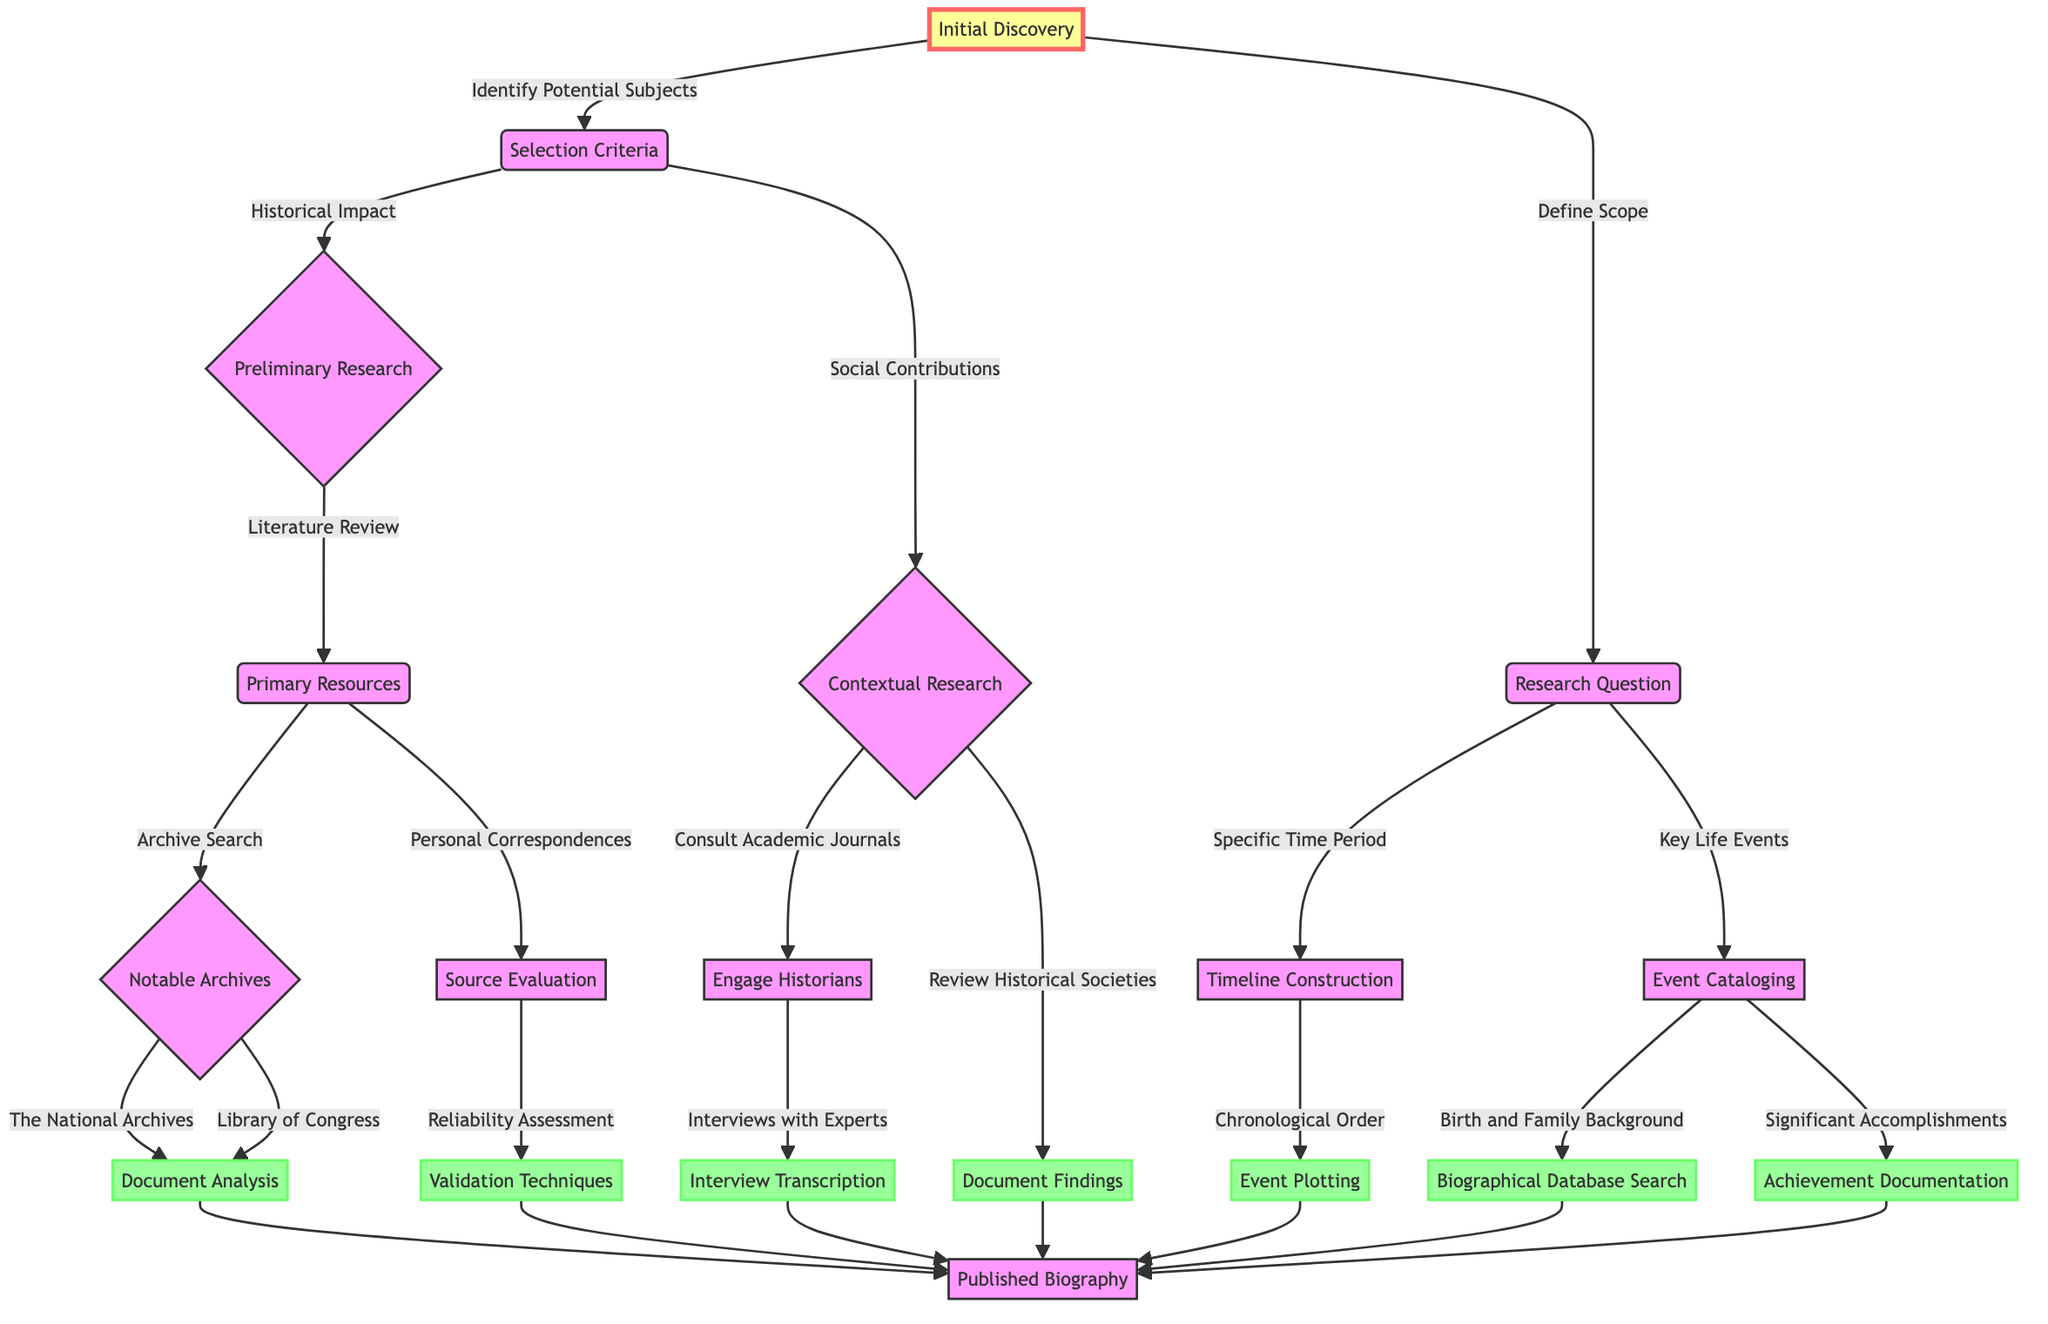What is the initial node in the diagram? The diagram starts with "Initial Discovery" as the first node.
Answer: Initial Discovery How many main pathways can be taken from "Selection Criteria"? There are two main pathways that can be taken from "Selection Criteria": "Historical Impact" and "Social Contributions".
Answer: 2 What is the last step before reaching the "Published Biography"? The last step that connects to the final node "Published Biography" can be "Document Analysis," "Validation Techniques," "Interview Transcription," "Document Findings," "Event Plotting," "Biographical Database Search," or "Achievement Documentation".
Answer: Document Analysis Which node follows "Define Scope"? "Define Scope" leads to the node "Research Question".
Answer: Research Question What sub-node follows "Literature Review"? The next node that follows "Literature Review" is "Primary Resources".
Answer: Primary Resources How many options follow "Contextual Research"? There are two options that follow "Contextual Research": "Consult Academic Journals" and "Review Historical Societies".
Answer: 2 What type of research approach is indicated by the connection from "Historical Impact"? The approach indicated by the connection from "Historical Impact" is "Preliminary Research".
Answer: Preliminary Research What kind of evaluation follows "Personal Correspondences"? The evaluation that follows "Personal Correspondences" is "Source Evaluation".
Answer: Source Evaluation What is the purpose of the "Document Analysis" node? The purpose of the "Document Analysis" node is to analyze documents obtained from notable archives like "The National Archives" and "Library of Congress".
Answer: Analyze documents 